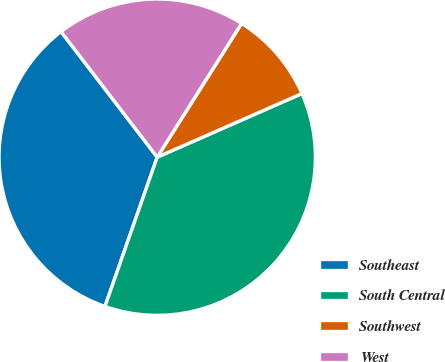Convert chart. <chart><loc_0><loc_0><loc_500><loc_500><pie_chart><fcel>Southeast<fcel>South Central<fcel>Southwest<fcel>West<nl><fcel>34.24%<fcel>36.95%<fcel>9.45%<fcel>19.36%<nl></chart> 